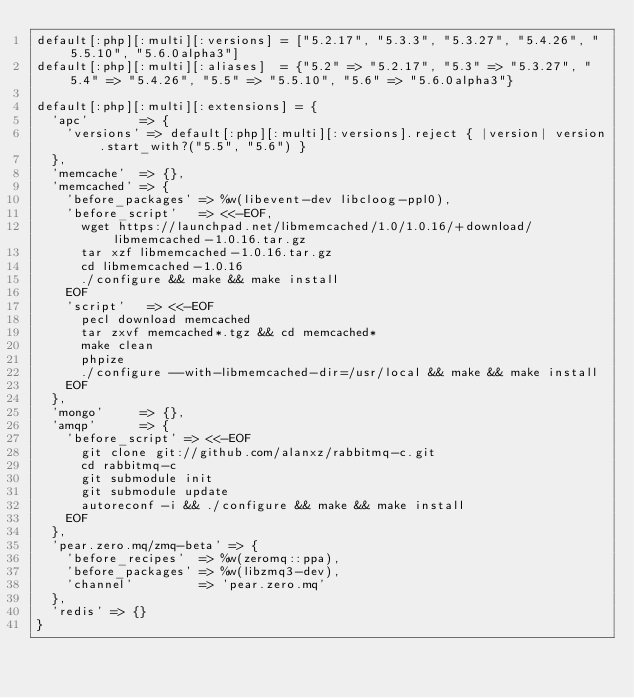<code> <loc_0><loc_0><loc_500><loc_500><_Ruby_>default[:php][:multi][:versions] = ["5.2.17", "5.3.3", "5.3.27", "5.4.26", "5.5.10", "5.6.0alpha3"]
default[:php][:multi][:aliases]  = {"5.2" => "5.2.17", "5.3" => "5.3.27", "5.4" => "5.4.26", "5.5" => "5.5.10", "5.6" => "5.6.0alpha3"}

default[:php][:multi][:extensions] = {
  'apc'       => {
    'versions' => default[:php][:multi][:versions].reject { |version| version.start_with?("5.5", "5.6") }
  },
  'memcache'  => {},
  'memcached' => {
    'before_packages' => %w(libevent-dev libcloog-ppl0),
    'before_script'   => <<-EOF,
      wget https://launchpad.net/libmemcached/1.0/1.0.16/+download/libmemcached-1.0.16.tar.gz
      tar xzf libmemcached-1.0.16.tar.gz
      cd libmemcached-1.0.16
      ./configure && make && make install
    EOF
    'script'   => <<-EOF
      pecl download memcached
      tar zxvf memcached*.tgz && cd memcached*
      make clean
      phpize
      ./configure --with-libmemcached-dir=/usr/local && make && make install
    EOF
  },
  'mongo'     => {},
  'amqp'      => {
    'before_script' => <<-EOF
      git clone git://github.com/alanxz/rabbitmq-c.git
      cd rabbitmq-c
      git submodule init
      git submodule update
      autoreconf -i && ./configure && make && make install
    EOF
  },
  'pear.zero.mq/zmq-beta' => {
    'before_recipes'  => %w(zeromq::ppa),
    'before_packages' => %w(libzmq3-dev),
    'channel'         => 'pear.zero.mq'
  },
  'redis' => {}
}
</code> 